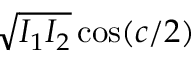<formula> <loc_0><loc_0><loc_500><loc_500>\sqrt { I _ { 1 } I _ { 2 } } \cos ( c / 2 )</formula> 